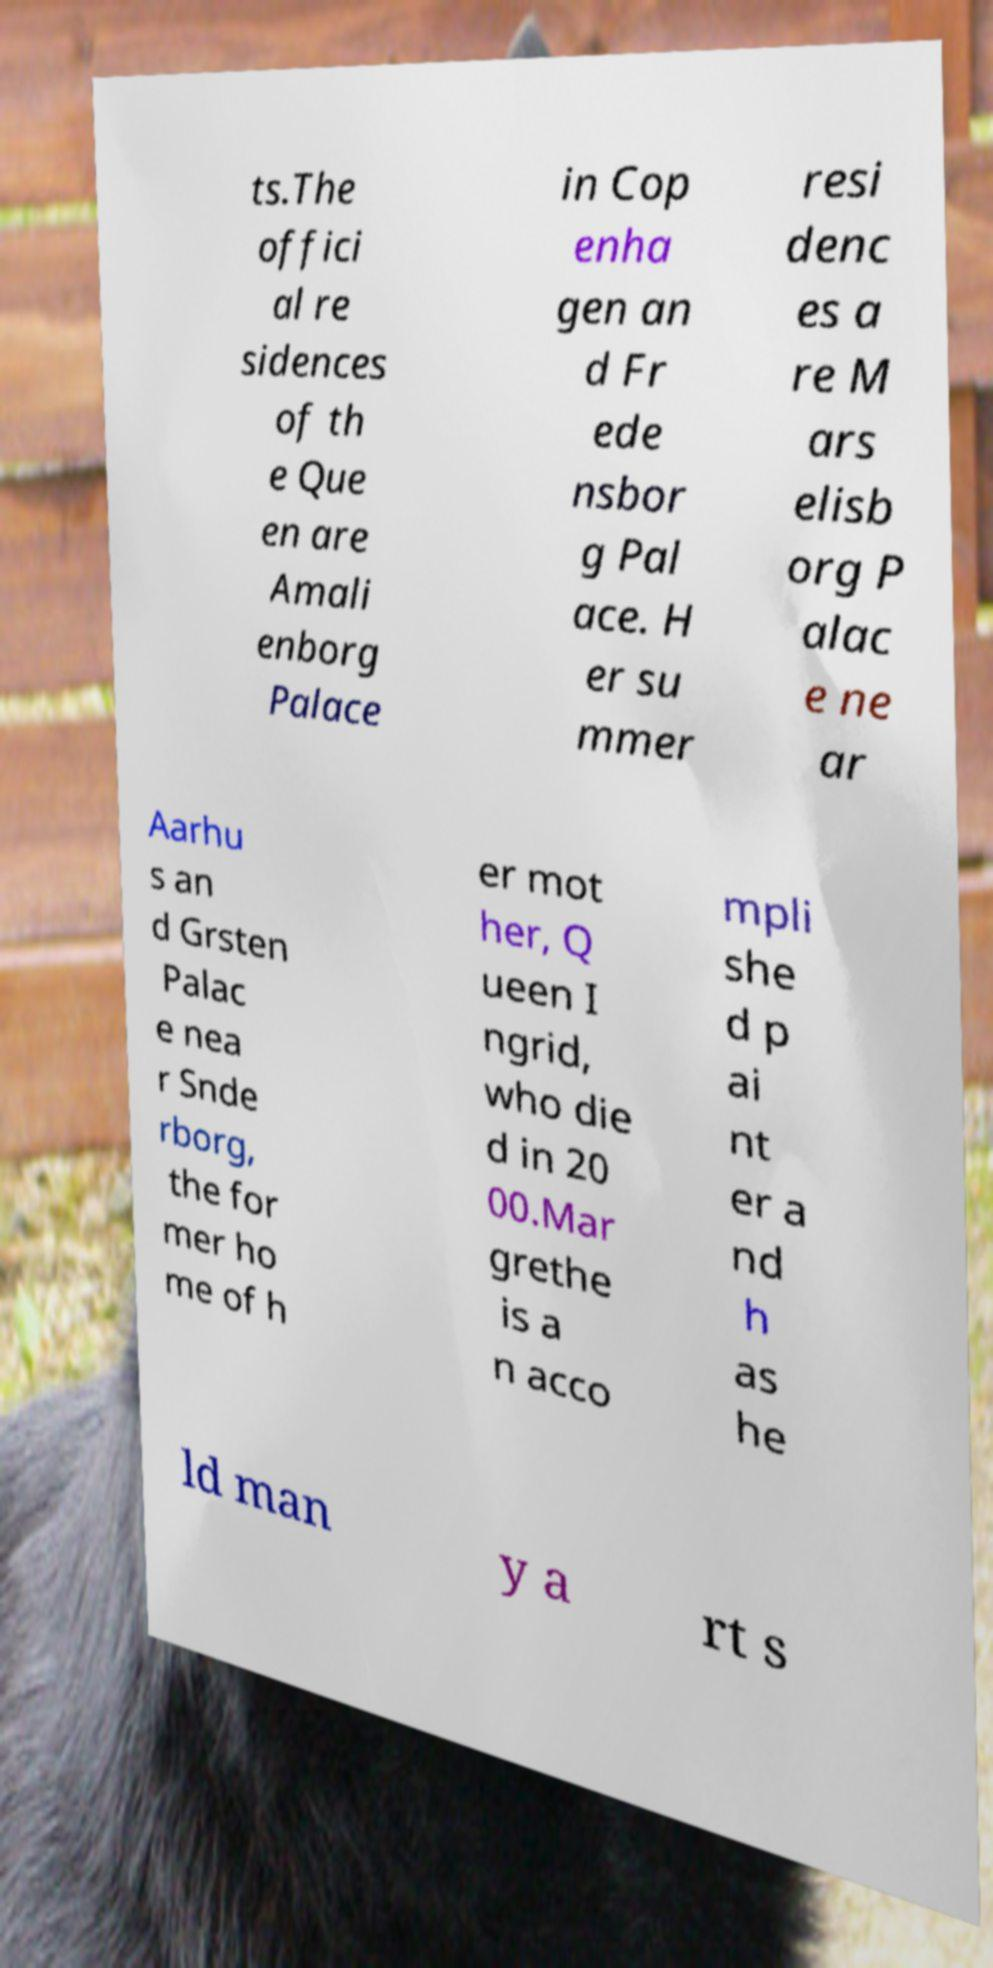Can you read and provide the text displayed in the image?This photo seems to have some interesting text. Can you extract and type it out for me? ts.The offici al re sidences of th e Que en are Amali enborg Palace in Cop enha gen an d Fr ede nsbor g Pal ace. H er su mmer resi denc es a re M ars elisb org P alac e ne ar Aarhu s an d Grsten Palac e nea r Snde rborg, the for mer ho me of h er mot her, Q ueen I ngrid, who die d in 20 00.Mar grethe is a n acco mpli she d p ai nt er a nd h as he ld man y a rt s 